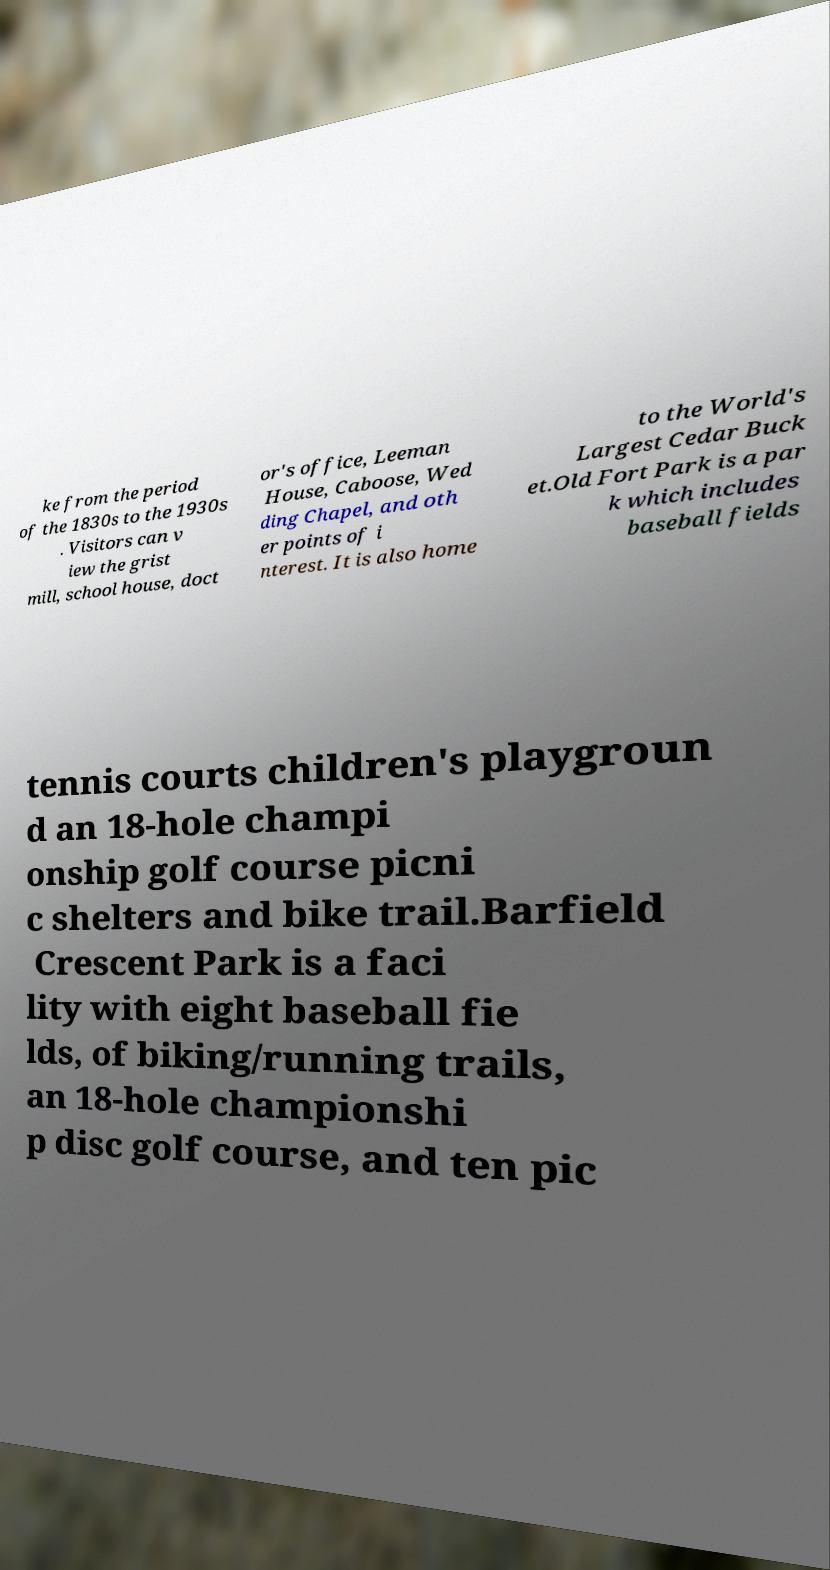For documentation purposes, I need the text within this image transcribed. Could you provide that? ke from the period of the 1830s to the 1930s . Visitors can v iew the grist mill, school house, doct or's office, Leeman House, Caboose, Wed ding Chapel, and oth er points of i nterest. It is also home to the World's Largest Cedar Buck et.Old Fort Park is a par k which includes baseball fields tennis courts children's playgroun d an 18-hole champi onship golf course picni c shelters and bike trail.Barfield Crescent Park is a faci lity with eight baseball fie lds, of biking/running trails, an 18-hole championshi p disc golf course, and ten pic 